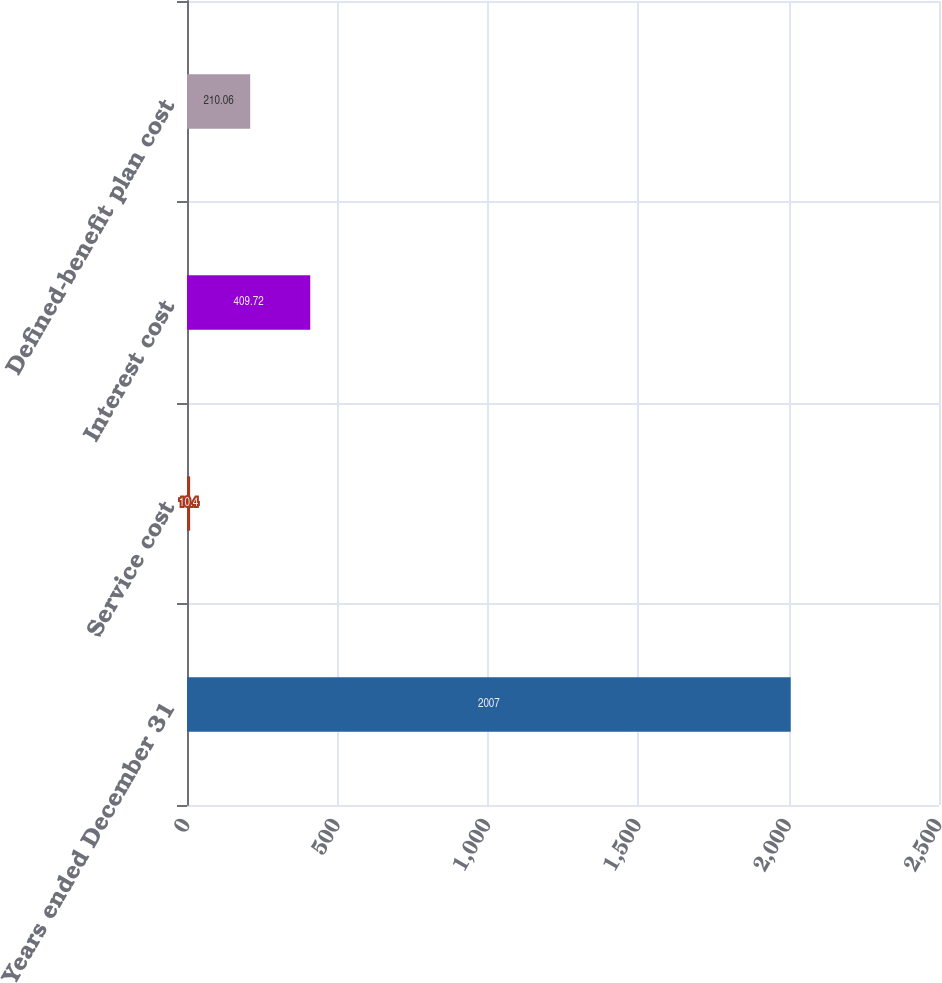<chart> <loc_0><loc_0><loc_500><loc_500><bar_chart><fcel>Years ended December 31<fcel>Service cost<fcel>Interest cost<fcel>Defined-benefit plan cost<nl><fcel>2007<fcel>10.4<fcel>409.72<fcel>210.06<nl></chart> 